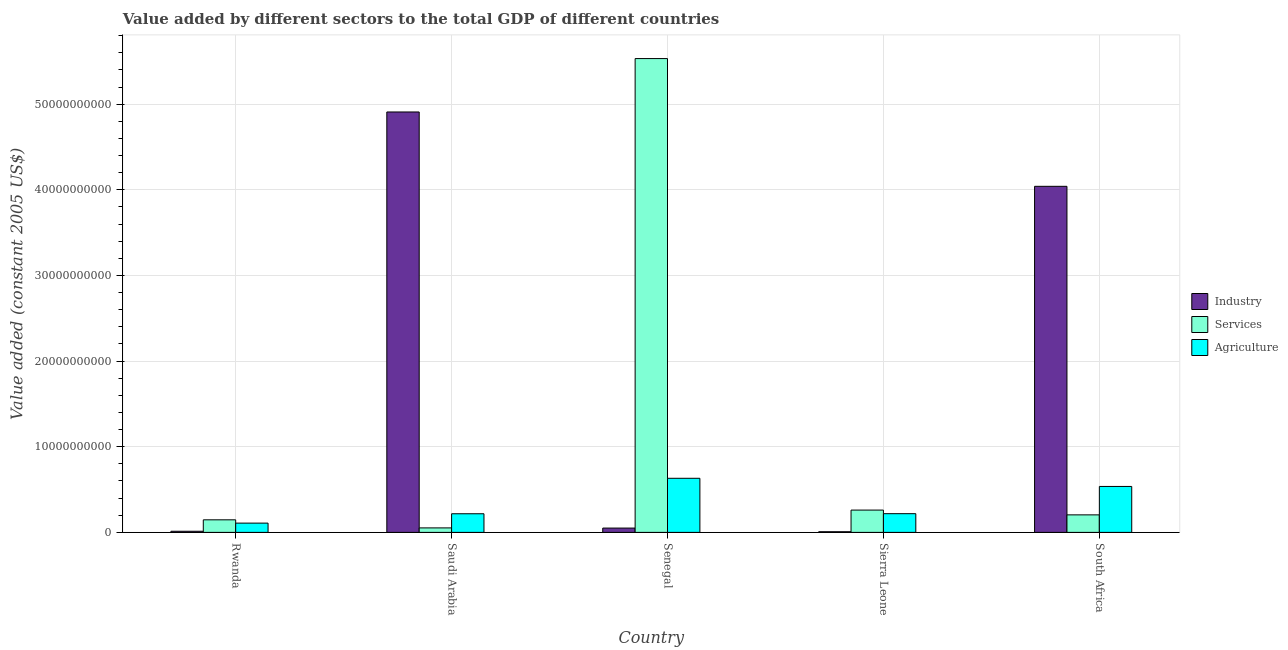How many groups of bars are there?
Provide a succinct answer. 5. Are the number of bars per tick equal to the number of legend labels?
Your response must be concise. Yes. How many bars are there on the 5th tick from the left?
Your answer should be very brief. 3. How many bars are there on the 5th tick from the right?
Keep it short and to the point. 3. What is the label of the 5th group of bars from the left?
Your answer should be very brief. South Africa. What is the value added by industrial sector in Sierra Leone?
Provide a short and direct response. 7.63e+07. Across all countries, what is the maximum value added by services?
Provide a short and direct response. 5.53e+1. Across all countries, what is the minimum value added by services?
Offer a very short reply. 5.24e+08. In which country was the value added by agricultural sector maximum?
Keep it short and to the point. Senegal. In which country was the value added by services minimum?
Offer a terse response. Saudi Arabia. What is the total value added by agricultural sector in the graph?
Provide a short and direct response. 1.71e+1. What is the difference between the value added by industrial sector in Saudi Arabia and that in Sierra Leone?
Keep it short and to the point. 4.90e+1. What is the difference between the value added by services in Senegal and the value added by industrial sector in Rwanda?
Give a very brief answer. 5.52e+1. What is the average value added by agricultural sector per country?
Offer a very short reply. 3.42e+09. What is the difference between the value added by industrial sector and value added by services in South Africa?
Your answer should be compact. 3.84e+1. In how many countries, is the value added by agricultural sector greater than 56000000000 US$?
Your answer should be compact. 0. What is the ratio of the value added by services in Rwanda to that in Sierra Leone?
Offer a very short reply. 0.56. Is the difference between the value added by services in Saudi Arabia and South Africa greater than the difference between the value added by agricultural sector in Saudi Arabia and South Africa?
Your answer should be very brief. Yes. What is the difference between the highest and the second highest value added by agricultural sector?
Your response must be concise. 9.52e+08. What is the difference between the highest and the lowest value added by industrial sector?
Your response must be concise. 4.90e+1. In how many countries, is the value added by industrial sector greater than the average value added by industrial sector taken over all countries?
Offer a terse response. 2. Is the sum of the value added by agricultural sector in Rwanda and Senegal greater than the maximum value added by services across all countries?
Your answer should be very brief. No. What does the 3rd bar from the left in Sierra Leone represents?
Your answer should be very brief. Agriculture. What does the 1st bar from the right in Rwanda represents?
Your response must be concise. Agriculture. Is it the case that in every country, the sum of the value added by industrial sector and value added by services is greater than the value added by agricultural sector?
Make the answer very short. Yes. How many bars are there?
Keep it short and to the point. 15. Are all the bars in the graph horizontal?
Provide a succinct answer. No. How many countries are there in the graph?
Provide a short and direct response. 5. Are the values on the major ticks of Y-axis written in scientific E-notation?
Provide a succinct answer. No. Does the graph contain grids?
Provide a short and direct response. Yes. How many legend labels are there?
Make the answer very short. 3. How are the legend labels stacked?
Offer a very short reply. Vertical. What is the title of the graph?
Offer a very short reply. Value added by different sectors to the total GDP of different countries. What is the label or title of the Y-axis?
Your answer should be very brief. Value added (constant 2005 US$). What is the Value added (constant 2005 US$) in Industry in Rwanda?
Your response must be concise. 1.31e+08. What is the Value added (constant 2005 US$) of Services in Rwanda?
Keep it short and to the point. 1.47e+09. What is the Value added (constant 2005 US$) in Agriculture in Rwanda?
Your answer should be very brief. 1.08e+09. What is the Value added (constant 2005 US$) of Industry in Saudi Arabia?
Your answer should be very brief. 4.91e+1. What is the Value added (constant 2005 US$) of Services in Saudi Arabia?
Your response must be concise. 5.24e+08. What is the Value added (constant 2005 US$) of Agriculture in Saudi Arabia?
Keep it short and to the point. 2.18e+09. What is the Value added (constant 2005 US$) in Industry in Senegal?
Offer a terse response. 5.04e+08. What is the Value added (constant 2005 US$) in Services in Senegal?
Offer a very short reply. 5.53e+1. What is the Value added (constant 2005 US$) of Agriculture in Senegal?
Your answer should be very brief. 6.32e+09. What is the Value added (constant 2005 US$) of Industry in Sierra Leone?
Offer a very short reply. 7.63e+07. What is the Value added (constant 2005 US$) of Services in Sierra Leone?
Your answer should be compact. 2.60e+09. What is the Value added (constant 2005 US$) of Agriculture in Sierra Leone?
Your response must be concise. 2.18e+09. What is the Value added (constant 2005 US$) of Industry in South Africa?
Your response must be concise. 4.04e+1. What is the Value added (constant 2005 US$) in Services in South Africa?
Make the answer very short. 2.05e+09. What is the Value added (constant 2005 US$) in Agriculture in South Africa?
Provide a succinct answer. 5.36e+09. Across all countries, what is the maximum Value added (constant 2005 US$) of Industry?
Keep it short and to the point. 4.91e+1. Across all countries, what is the maximum Value added (constant 2005 US$) of Services?
Provide a short and direct response. 5.53e+1. Across all countries, what is the maximum Value added (constant 2005 US$) of Agriculture?
Give a very brief answer. 6.32e+09. Across all countries, what is the minimum Value added (constant 2005 US$) in Industry?
Provide a short and direct response. 7.63e+07. Across all countries, what is the minimum Value added (constant 2005 US$) of Services?
Keep it short and to the point. 5.24e+08. Across all countries, what is the minimum Value added (constant 2005 US$) of Agriculture?
Make the answer very short. 1.08e+09. What is the total Value added (constant 2005 US$) of Industry in the graph?
Offer a terse response. 9.02e+1. What is the total Value added (constant 2005 US$) of Services in the graph?
Offer a very short reply. 6.20e+1. What is the total Value added (constant 2005 US$) in Agriculture in the graph?
Offer a very short reply. 1.71e+1. What is the difference between the Value added (constant 2005 US$) in Industry in Rwanda and that in Saudi Arabia?
Keep it short and to the point. -4.90e+1. What is the difference between the Value added (constant 2005 US$) of Services in Rwanda and that in Saudi Arabia?
Keep it short and to the point. 9.43e+08. What is the difference between the Value added (constant 2005 US$) of Agriculture in Rwanda and that in Saudi Arabia?
Give a very brief answer. -1.09e+09. What is the difference between the Value added (constant 2005 US$) in Industry in Rwanda and that in Senegal?
Your answer should be compact. -3.74e+08. What is the difference between the Value added (constant 2005 US$) of Services in Rwanda and that in Senegal?
Offer a very short reply. -5.39e+1. What is the difference between the Value added (constant 2005 US$) in Agriculture in Rwanda and that in Senegal?
Offer a terse response. -5.23e+09. What is the difference between the Value added (constant 2005 US$) of Industry in Rwanda and that in Sierra Leone?
Keep it short and to the point. 5.43e+07. What is the difference between the Value added (constant 2005 US$) in Services in Rwanda and that in Sierra Leone?
Your answer should be very brief. -1.14e+09. What is the difference between the Value added (constant 2005 US$) of Agriculture in Rwanda and that in Sierra Leone?
Your answer should be very brief. -1.10e+09. What is the difference between the Value added (constant 2005 US$) in Industry in Rwanda and that in South Africa?
Provide a succinct answer. -4.03e+1. What is the difference between the Value added (constant 2005 US$) in Services in Rwanda and that in South Africa?
Offer a terse response. -5.79e+08. What is the difference between the Value added (constant 2005 US$) of Agriculture in Rwanda and that in South Africa?
Keep it short and to the point. -4.28e+09. What is the difference between the Value added (constant 2005 US$) of Industry in Saudi Arabia and that in Senegal?
Make the answer very short. 4.86e+1. What is the difference between the Value added (constant 2005 US$) of Services in Saudi Arabia and that in Senegal?
Offer a terse response. -5.48e+1. What is the difference between the Value added (constant 2005 US$) of Agriculture in Saudi Arabia and that in Senegal?
Offer a very short reply. -4.14e+09. What is the difference between the Value added (constant 2005 US$) of Industry in Saudi Arabia and that in Sierra Leone?
Keep it short and to the point. 4.90e+1. What is the difference between the Value added (constant 2005 US$) in Services in Saudi Arabia and that in Sierra Leone?
Keep it short and to the point. -2.08e+09. What is the difference between the Value added (constant 2005 US$) of Agriculture in Saudi Arabia and that in Sierra Leone?
Your answer should be very brief. -9.53e+06. What is the difference between the Value added (constant 2005 US$) of Industry in Saudi Arabia and that in South Africa?
Your answer should be compact. 8.68e+09. What is the difference between the Value added (constant 2005 US$) in Services in Saudi Arabia and that in South Africa?
Provide a short and direct response. -1.52e+09. What is the difference between the Value added (constant 2005 US$) in Agriculture in Saudi Arabia and that in South Africa?
Your response must be concise. -3.19e+09. What is the difference between the Value added (constant 2005 US$) of Industry in Senegal and that in Sierra Leone?
Keep it short and to the point. 4.28e+08. What is the difference between the Value added (constant 2005 US$) in Services in Senegal and that in Sierra Leone?
Keep it short and to the point. 5.27e+1. What is the difference between the Value added (constant 2005 US$) in Agriculture in Senegal and that in Sierra Leone?
Your answer should be compact. 4.13e+09. What is the difference between the Value added (constant 2005 US$) of Industry in Senegal and that in South Africa?
Your answer should be compact. -3.99e+1. What is the difference between the Value added (constant 2005 US$) in Services in Senegal and that in South Africa?
Provide a succinct answer. 5.33e+1. What is the difference between the Value added (constant 2005 US$) in Agriculture in Senegal and that in South Africa?
Your response must be concise. 9.52e+08. What is the difference between the Value added (constant 2005 US$) in Industry in Sierra Leone and that in South Africa?
Give a very brief answer. -4.03e+1. What is the difference between the Value added (constant 2005 US$) in Services in Sierra Leone and that in South Africa?
Ensure brevity in your answer.  5.59e+08. What is the difference between the Value added (constant 2005 US$) of Agriculture in Sierra Leone and that in South Africa?
Provide a succinct answer. -3.18e+09. What is the difference between the Value added (constant 2005 US$) of Industry in Rwanda and the Value added (constant 2005 US$) of Services in Saudi Arabia?
Your response must be concise. -3.93e+08. What is the difference between the Value added (constant 2005 US$) of Industry in Rwanda and the Value added (constant 2005 US$) of Agriculture in Saudi Arabia?
Offer a very short reply. -2.04e+09. What is the difference between the Value added (constant 2005 US$) of Services in Rwanda and the Value added (constant 2005 US$) of Agriculture in Saudi Arabia?
Make the answer very short. -7.09e+08. What is the difference between the Value added (constant 2005 US$) of Industry in Rwanda and the Value added (constant 2005 US$) of Services in Senegal?
Keep it short and to the point. -5.52e+1. What is the difference between the Value added (constant 2005 US$) of Industry in Rwanda and the Value added (constant 2005 US$) of Agriculture in Senegal?
Give a very brief answer. -6.19e+09. What is the difference between the Value added (constant 2005 US$) of Services in Rwanda and the Value added (constant 2005 US$) of Agriculture in Senegal?
Your answer should be compact. -4.85e+09. What is the difference between the Value added (constant 2005 US$) of Industry in Rwanda and the Value added (constant 2005 US$) of Services in Sierra Leone?
Provide a short and direct response. -2.47e+09. What is the difference between the Value added (constant 2005 US$) in Industry in Rwanda and the Value added (constant 2005 US$) in Agriculture in Sierra Leone?
Give a very brief answer. -2.05e+09. What is the difference between the Value added (constant 2005 US$) in Services in Rwanda and the Value added (constant 2005 US$) in Agriculture in Sierra Leone?
Give a very brief answer. -7.18e+08. What is the difference between the Value added (constant 2005 US$) in Industry in Rwanda and the Value added (constant 2005 US$) in Services in South Africa?
Give a very brief answer. -1.91e+09. What is the difference between the Value added (constant 2005 US$) in Industry in Rwanda and the Value added (constant 2005 US$) in Agriculture in South Africa?
Offer a terse response. -5.23e+09. What is the difference between the Value added (constant 2005 US$) of Services in Rwanda and the Value added (constant 2005 US$) of Agriculture in South Africa?
Your response must be concise. -3.90e+09. What is the difference between the Value added (constant 2005 US$) in Industry in Saudi Arabia and the Value added (constant 2005 US$) in Services in Senegal?
Offer a very short reply. -6.24e+09. What is the difference between the Value added (constant 2005 US$) of Industry in Saudi Arabia and the Value added (constant 2005 US$) of Agriculture in Senegal?
Your response must be concise. 4.28e+1. What is the difference between the Value added (constant 2005 US$) of Services in Saudi Arabia and the Value added (constant 2005 US$) of Agriculture in Senegal?
Make the answer very short. -5.79e+09. What is the difference between the Value added (constant 2005 US$) of Industry in Saudi Arabia and the Value added (constant 2005 US$) of Services in Sierra Leone?
Your answer should be very brief. 4.65e+1. What is the difference between the Value added (constant 2005 US$) in Industry in Saudi Arabia and the Value added (constant 2005 US$) in Agriculture in Sierra Leone?
Offer a terse response. 4.69e+1. What is the difference between the Value added (constant 2005 US$) in Services in Saudi Arabia and the Value added (constant 2005 US$) in Agriculture in Sierra Leone?
Keep it short and to the point. -1.66e+09. What is the difference between the Value added (constant 2005 US$) in Industry in Saudi Arabia and the Value added (constant 2005 US$) in Services in South Africa?
Provide a succinct answer. 4.70e+1. What is the difference between the Value added (constant 2005 US$) of Industry in Saudi Arabia and the Value added (constant 2005 US$) of Agriculture in South Africa?
Make the answer very short. 4.37e+1. What is the difference between the Value added (constant 2005 US$) of Services in Saudi Arabia and the Value added (constant 2005 US$) of Agriculture in South Africa?
Provide a succinct answer. -4.84e+09. What is the difference between the Value added (constant 2005 US$) of Industry in Senegal and the Value added (constant 2005 US$) of Services in Sierra Leone?
Offer a very short reply. -2.10e+09. What is the difference between the Value added (constant 2005 US$) of Industry in Senegal and the Value added (constant 2005 US$) of Agriculture in Sierra Leone?
Keep it short and to the point. -1.68e+09. What is the difference between the Value added (constant 2005 US$) of Services in Senegal and the Value added (constant 2005 US$) of Agriculture in Sierra Leone?
Provide a short and direct response. 5.31e+1. What is the difference between the Value added (constant 2005 US$) in Industry in Senegal and the Value added (constant 2005 US$) in Services in South Africa?
Make the answer very short. -1.54e+09. What is the difference between the Value added (constant 2005 US$) of Industry in Senegal and the Value added (constant 2005 US$) of Agriculture in South Africa?
Your answer should be very brief. -4.86e+09. What is the difference between the Value added (constant 2005 US$) of Services in Senegal and the Value added (constant 2005 US$) of Agriculture in South Africa?
Offer a terse response. 5.00e+1. What is the difference between the Value added (constant 2005 US$) in Industry in Sierra Leone and the Value added (constant 2005 US$) in Services in South Africa?
Offer a terse response. -1.97e+09. What is the difference between the Value added (constant 2005 US$) of Industry in Sierra Leone and the Value added (constant 2005 US$) of Agriculture in South Africa?
Ensure brevity in your answer.  -5.29e+09. What is the difference between the Value added (constant 2005 US$) in Services in Sierra Leone and the Value added (constant 2005 US$) in Agriculture in South Africa?
Your response must be concise. -2.76e+09. What is the average Value added (constant 2005 US$) in Industry per country?
Your answer should be very brief. 1.80e+1. What is the average Value added (constant 2005 US$) of Services per country?
Your answer should be compact. 1.24e+1. What is the average Value added (constant 2005 US$) of Agriculture per country?
Your answer should be compact. 3.42e+09. What is the difference between the Value added (constant 2005 US$) in Industry and Value added (constant 2005 US$) in Services in Rwanda?
Your answer should be compact. -1.34e+09. What is the difference between the Value added (constant 2005 US$) in Industry and Value added (constant 2005 US$) in Agriculture in Rwanda?
Your response must be concise. -9.52e+08. What is the difference between the Value added (constant 2005 US$) of Services and Value added (constant 2005 US$) of Agriculture in Rwanda?
Provide a short and direct response. 3.84e+08. What is the difference between the Value added (constant 2005 US$) in Industry and Value added (constant 2005 US$) in Services in Saudi Arabia?
Your answer should be compact. 4.86e+1. What is the difference between the Value added (constant 2005 US$) of Industry and Value added (constant 2005 US$) of Agriculture in Saudi Arabia?
Your answer should be compact. 4.69e+1. What is the difference between the Value added (constant 2005 US$) of Services and Value added (constant 2005 US$) of Agriculture in Saudi Arabia?
Offer a very short reply. -1.65e+09. What is the difference between the Value added (constant 2005 US$) in Industry and Value added (constant 2005 US$) in Services in Senegal?
Your answer should be compact. -5.48e+1. What is the difference between the Value added (constant 2005 US$) of Industry and Value added (constant 2005 US$) of Agriculture in Senegal?
Your answer should be compact. -5.81e+09. What is the difference between the Value added (constant 2005 US$) of Services and Value added (constant 2005 US$) of Agriculture in Senegal?
Make the answer very short. 4.90e+1. What is the difference between the Value added (constant 2005 US$) in Industry and Value added (constant 2005 US$) in Services in Sierra Leone?
Provide a succinct answer. -2.53e+09. What is the difference between the Value added (constant 2005 US$) of Industry and Value added (constant 2005 US$) of Agriculture in Sierra Leone?
Make the answer very short. -2.11e+09. What is the difference between the Value added (constant 2005 US$) in Services and Value added (constant 2005 US$) in Agriculture in Sierra Leone?
Offer a terse response. 4.19e+08. What is the difference between the Value added (constant 2005 US$) of Industry and Value added (constant 2005 US$) of Services in South Africa?
Ensure brevity in your answer.  3.84e+1. What is the difference between the Value added (constant 2005 US$) of Industry and Value added (constant 2005 US$) of Agriculture in South Africa?
Provide a succinct answer. 3.50e+1. What is the difference between the Value added (constant 2005 US$) of Services and Value added (constant 2005 US$) of Agriculture in South Africa?
Provide a short and direct response. -3.32e+09. What is the ratio of the Value added (constant 2005 US$) in Industry in Rwanda to that in Saudi Arabia?
Your response must be concise. 0. What is the ratio of the Value added (constant 2005 US$) in Services in Rwanda to that in Saudi Arabia?
Make the answer very short. 2.8. What is the ratio of the Value added (constant 2005 US$) in Agriculture in Rwanda to that in Saudi Arabia?
Offer a very short reply. 0.5. What is the ratio of the Value added (constant 2005 US$) of Industry in Rwanda to that in Senegal?
Give a very brief answer. 0.26. What is the ratio of the Value added (constant 2005 US$) in Services in Rwanda to that in Senegal?
Provide a short and direct response. 0.03. What is the ratio of the Value added (constant 2005 US$) in Agriculture in Rwanda to that in Senegal?
Keep it short and to the point. 0.17. What is the ratio of the Value added (constant 2005 US$) in Industry in Rwanda to that in Sierra Leone?
Your response must be concise. 1.71. What is the ratio of the Value added (constant 2005 US$) of Services in Rwanda to that in Sierra Leone?
Your response must be concise. 0.56. What is the ratio of the Value added (constant 2005 US$) in Agriculture in Rwanda to that in Sierra Leone?
Give a very brief answer. 0.5. What is the ratio of the Value added (constant 2005 US$) of Industry in Rwanda to that in South Africa?
Provide a succinct answer. 0. What is the ratio of the Value added (constant 2005 US$) in Services in Rwanda to that in South Africa?
Your response must be concise. 0.72. What is the ratio of the Value added (constant 2005 US$) in Agriculture in Rwanda to that in South Africa?
Give a very brief answer. 0.2. What is the ratio of the Value added (constant 2005 US$) of Industry in Saudi Arabia to that in Senegal?
Give a very brief answer. 97.33. What is the ratio of the Value added (constant 2005 US$) of Services in Saudi Arabia to that in Senegal?
Offer a terse response. 0.01. What is the ratio of the Value added (constant 2005 US$) in Agriculture in Saudi Arabia to that in Senegal?
Your answer should be very brief. 0.34. What is the ratio of the Value added (constant 2005 US$) in Industry in Saudi Arabia to that in Sierra Leone?
Your answer should be very brief. 643.59. What is the ratio of the Value added (constant 2005 US$) in Services in Saudi Arabia to that in Sierra Leone?
Give a very brief answer. 0.2. What is the ratio of the Value added (constant 2005 US$) of Agriculture in Saudi Arabia to that in Sierra Leone?
Give a very brief answer. 1. What is the ratio of the Value added (constant 2005 US$) of Industry in Saudi Arabia to that in South Africa?
Your response must be concise. 1.21. What is the ratio of the Value added (constant 2005 US$) of Services in Saudi Arabia to that in South Africa?
Ensure brevity in your answer.  0.26. What is the ratio of the Value added (constant 2005 US$) in Agriculture in Saudi Arabia to that in South Africa?
Keep it short and to the point. 0.41. What is the ratio of the Value added (constant 2005 US$) in Industry in Senegal to that in Sierra Leone?
Ensure brevity in your answer.  6.61. What is the ratio of the Value added (constant 2005 US$) in Services in Senegal to that in Sierra Leone?
Offer a terse response. 21.24. What is the ratio of the Value added (constant 2005 US$) of Agriculture in Senegal to that in Sierra Leone?
Make the answer very short. 2.89. What is the ratio of the Value added (constant 2005 US$) in Industry in Senegal to that in South Africa?
Offer a terse response. 0.01. What is the ratio of the Value added (constant 2005 US$) of Services in Senegal to that in South Africa?
Ensure brevity in your answer.  27.05. What is the ratio of the Value added (constant 2005 US$) of Agriculture in Senegal to that in South Africa?
Make the answer very short. 1.18. What is the ratio of the Value added (constant 2005 US$) in Industry in Sierra Leone to that in South Africa?
Ensure brevity in your answer.  0. What is the ratio of the Value added (constant 2005 US$) of Services in Sierra Leone to that in South Africa?
Provide a succinct answer. 1.27. What is the ratio of the Value added (constant 2005 US$) of Agriculture in Sierra Leone to that in South Africa?
Your answer should be very brief. 0.41. What is the difference between the highest and the second highest Value added (constant 2005 US$) of Industry?
Offer a terse response. 8.68e+09. What is the difference between the highest and the second highest Value added (constant 2005 US$) of Services?
Ensure brevity in your answer.  5.27e+1. What is the difference between the highest and the second highest Value added (constant 2005 US$) of Agriculture?
Give a very brief answer. 9.52e+08. What is the difference between the highest and the lowest Value added (constant 2005 US$) in Industry?
Your response must be concise. 4.90e+1. What is the difference between the highest and the lowest Value added (constant 2005 US$) of Services?
Your answer should be compact. 5.48e+1. What is the difference between the highest and the lowest Value added (constant 2005 US$) of Agriculture?
Your answer should be compact. 5.23e+09. 